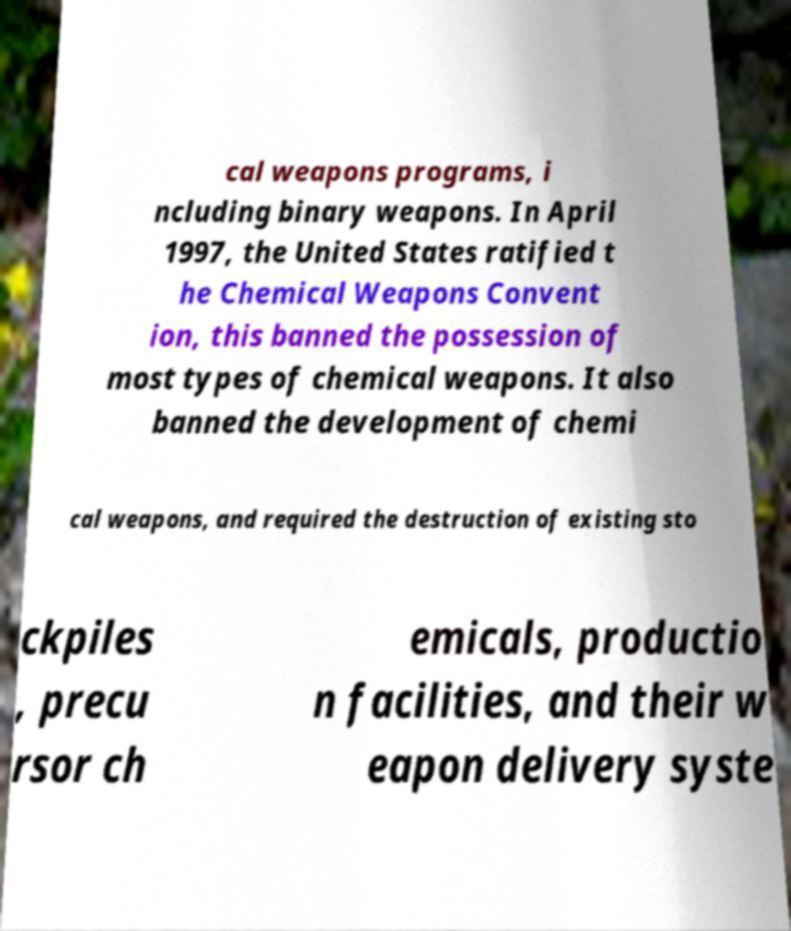I need the written content from this picture converted into text. Can you do that? cal weapons programs, i ncluding binary weapons. In April 1997, the United States ratified t he Chemical Weapons Convent ion, this banned the possession of most types of chemical weapons. It also banned the development of chemi cal weapons, and required the destruction of existing sto ckpiles , precu rsor ch emicals, productio n facilities, and their w eapon delivery syste 